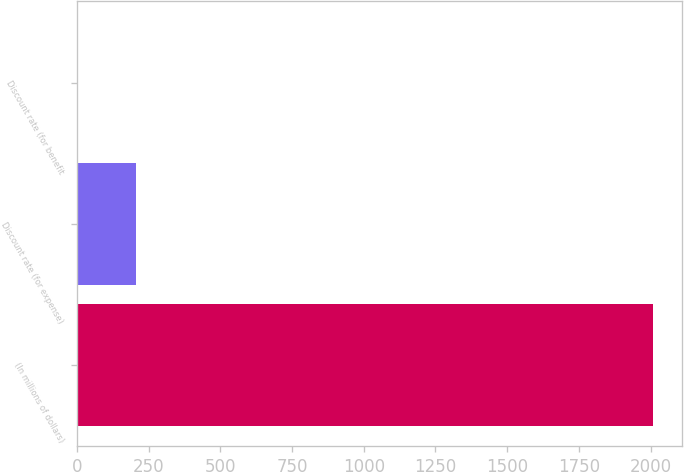Convert chart. <chart><loc_0><loc_0><loc_500><loc_500><bar_chart><fcel>(In millions of dollars)<fcel>Discount rate (for expense)<fcel>Discount rate (for benefit<nl><fcel>2010<fcel>205.95<fcel>5.5<nl></chart> 